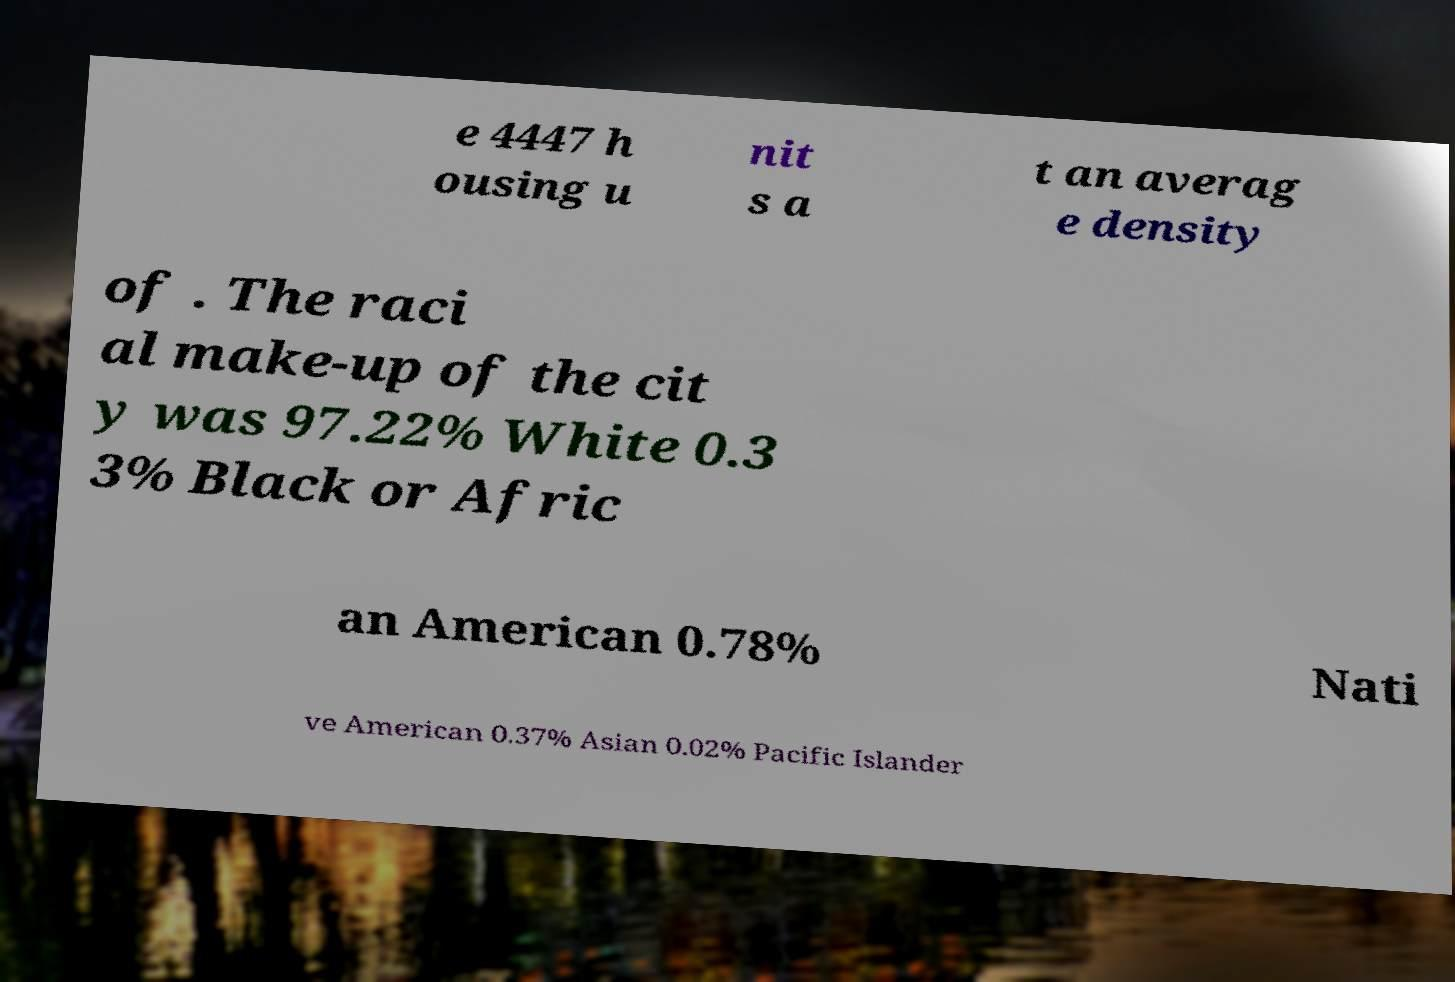Could you extract and type out the text from this image? e 4447 h ousing u nit s a t an averag e density of . The raci al make-up of the cit y was 97.22% White 0.3 3% Black or Afric an American 0.78% Nati ve American 0.37% Asian 0.02% Pacific Islander 